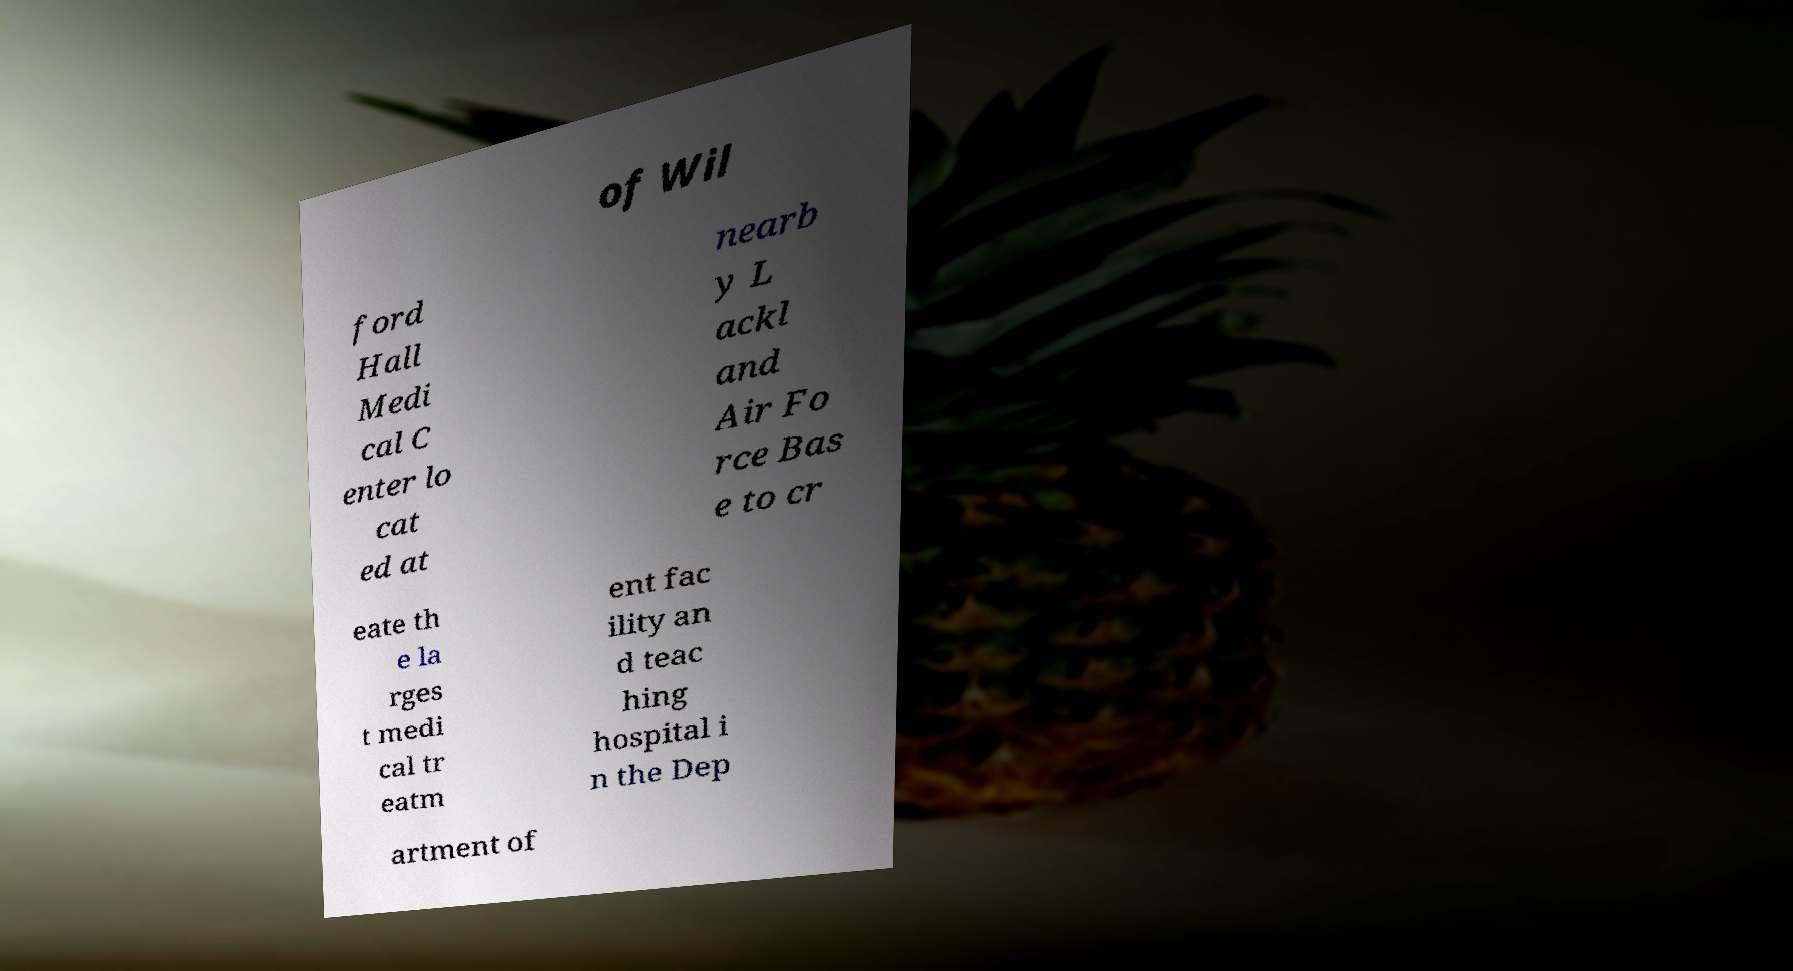There's text embedded in this image that I need extracted. Can you transcribe it verbatim? of Wil ford Hall Medi cal C enter lo cat ed at nearb y L ackl and Air Fo rce Bas e to cr eate th e la rges t medi cal tr eatm ent fac ility an d teac hing hospital i n the Dep artment of 